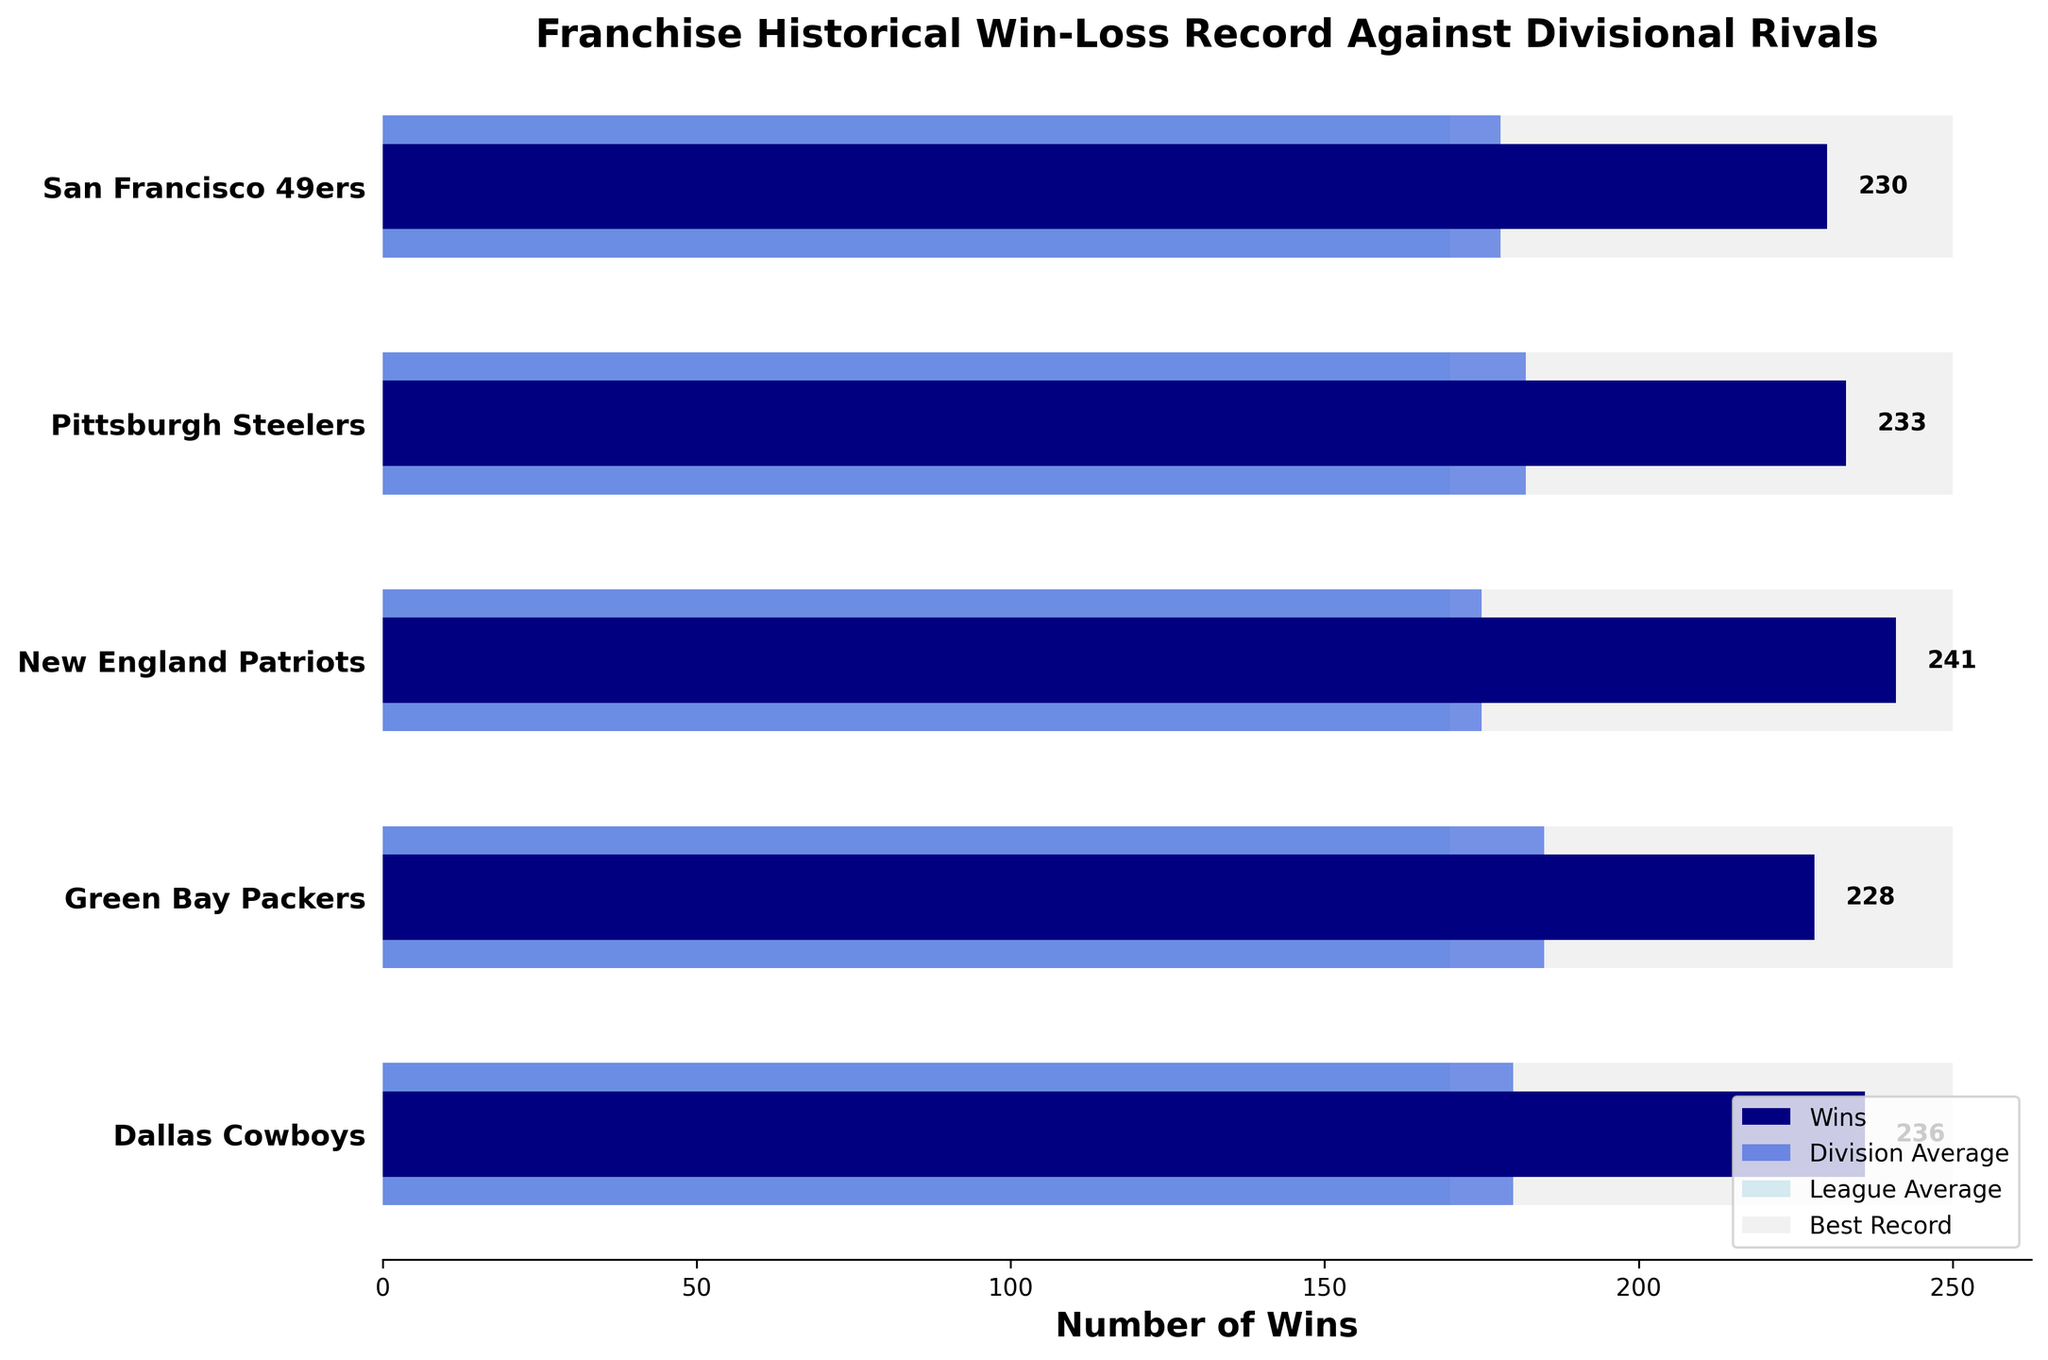What is the title of the chart? The title of the chart is displayed prominently at the top of the figure, indicating the main focus of the visual data.
Answer: Franchise Historical Win-Loss Record Against Divisional Rivals How many teams are included in the chart? The chart displays horizontal bars for each team, which you can count by looking at the y-axis labels. There are 5 team labels on the y-axis.
Answer: 5 Which team has the highest number of wins? By looking at the length of the dark navy bars, which represent the number of wins, you can see which one is the longest. The longest bar corresponds to the Dallas Cowboys with 236 wins.
Answer: Dallas Cowboys What are the values for the league average and the best record shown in the chart? The league average and the best record are represented by fixed-length bars (light blue and light gray, respectively) that span the same distance for all teams. The chart shows that the values are 170 for the league average and 250 for the best record.
Answer: 170 and 250 How does the win record of the Pittsburgh Steelers compare to their division average? Compare the length of the dark navy bar for the Pittsburgh Steelers (wins) to the royal blue bar (division average) for the same team. The Steelers have 233 wins, which is higher than their division average of 182.
Answer: Higher Which team has a division average closest to the league average? Find the team whose division average bar (royal blue) is closest in length to the league average bar (light blue, which is the same for all teams, i.e., 170). The closest division average to 170 is that of the New England Patriots at 175.
Answer: New England Patriots Calculate the difference between the best record and the wins for the San Francisco 49ers. Subtract the number of wins for the 49ers (230) from the best record (250): 250 - 230 = 20.
Answer: 20 Which team is the farthest from achieving the best record? Calculate the difference between the best record (250) and the wins for each team and find the largest difference. The Packers have 228 wins, the highest number of wins after the Cowboys and Patriots. However, we focus on the 'farthest' term: the Green Bay Packers have the most difference after the Cowboys with: 250 - 228 = 22.
Answer: Green Bay Packers What is the average number of wins for all the teams displayed? Add up the number of wins for all the teams and divide by the number of teams. (236 + 228 + 241 + 233 + 230) / 5 = 1168 / 5 = 233.6.
Answer: 233.6 Among the teams shown, which team has the smallest difference between their division average and their actual wins? For each team, subtract the division average from their number of wins and find the smallest difference. 
- Cowboys: 236 - 180 = 56
- Packers: 228 - 185 = 43
- Patriots: 241 - 175 = 66
- Steelers: 233 - 182 = 51
- 49ers: 230 - 178 = 52
The Packers have the smallest difference of 43.
Answer: Green Bay Packers 